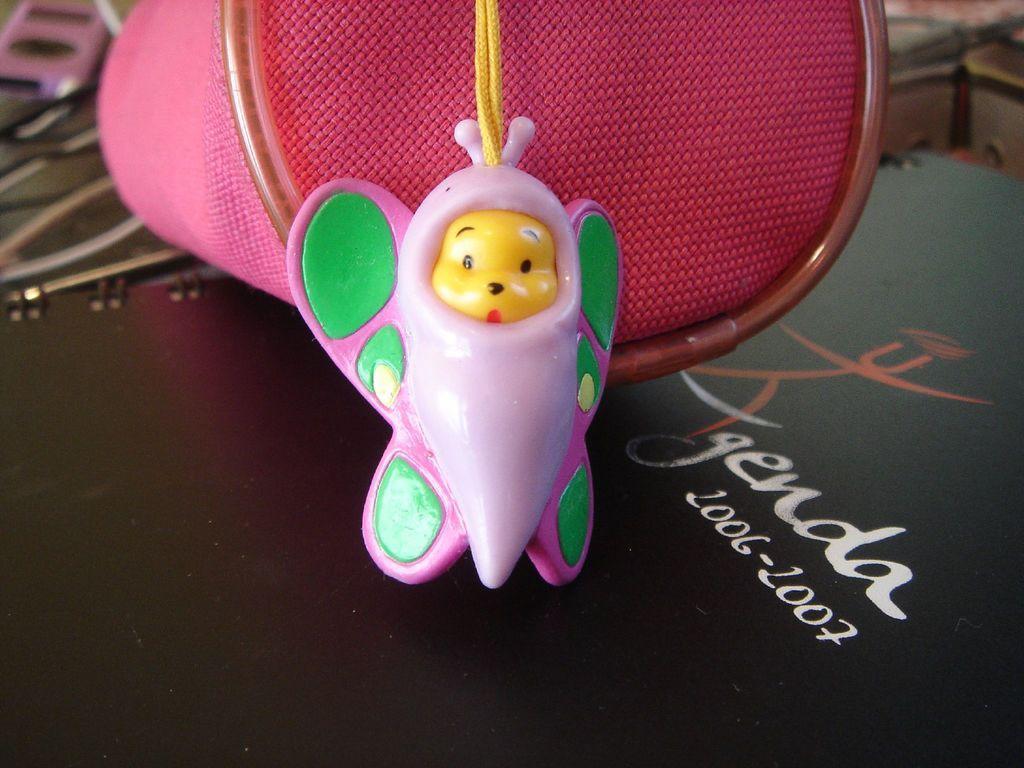Can you describe this image briefly? In this image we can see a toy, beside that we can see an object, we can see text written on the surface. 